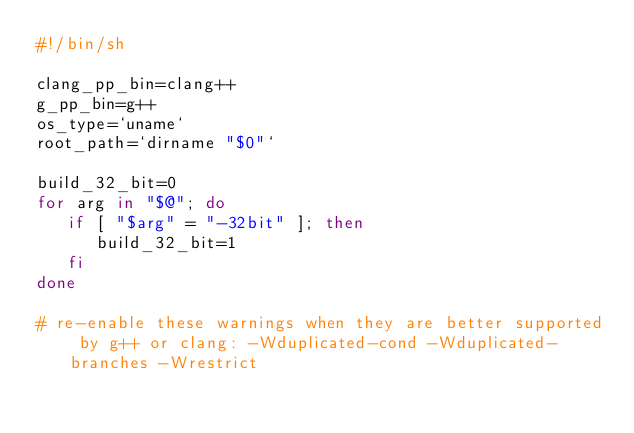Convert code to text. <code><loc_0><loc_0><loc_500><loc_500><_Bash_>#!/bin/sh

clang_pp_bin=clang++
g_pp_bin=g++
os_type=`uname`
root_path=`dirname "$0"`

build_32_bit=0
for arg in "$@"; do
   if [ "$arg" = "-32bit" ]; then
      build_32_bit=1
   fi
done

# re-enable these warnings when they are better supported by g++ or clang: -Wduplicated-cond -Wduplicated-branches -Wrestrict</code> 